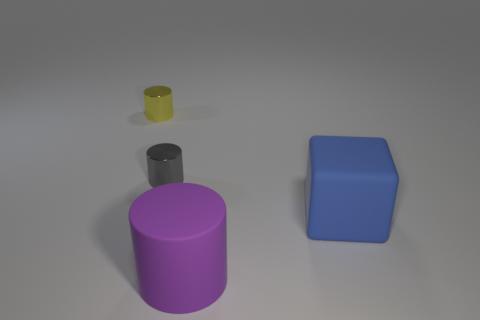Add 2 red metallic spheres. How many objects exist? 6 Subtract all blocks. How many objects are left? 3 Subtract 0 purple spheres. How many objects are left? 4 Subtract all brown shiny things. Subtract all cubes. How many objects are left? 3 Add 4 matte things. How many matte things are left? 6 Add 2 large purple things. How many large purple things exist? 3 